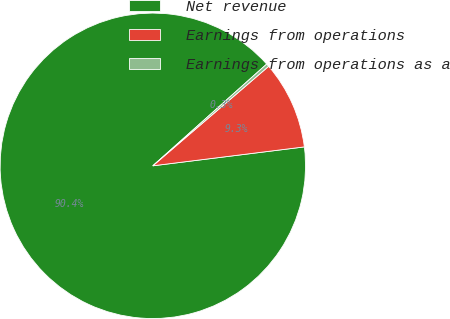<chart> <loc_0><loc_0><loc_500><loc_500><pie_chart><fcel>Net revenue<fcel>Earnings from operations<fcel>Earnings from operations as a<nl><fcel>90.38%<fcel>9.32%<fcel>0.31%<nl></chart> 